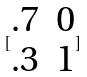Convert formula to latex. <formula><loc_0><loc_0><loc_500><loc_500>[ \begin{matrix} . 7 & 0 \\ . 3 & 1 \end{matrix} ]</formula> 